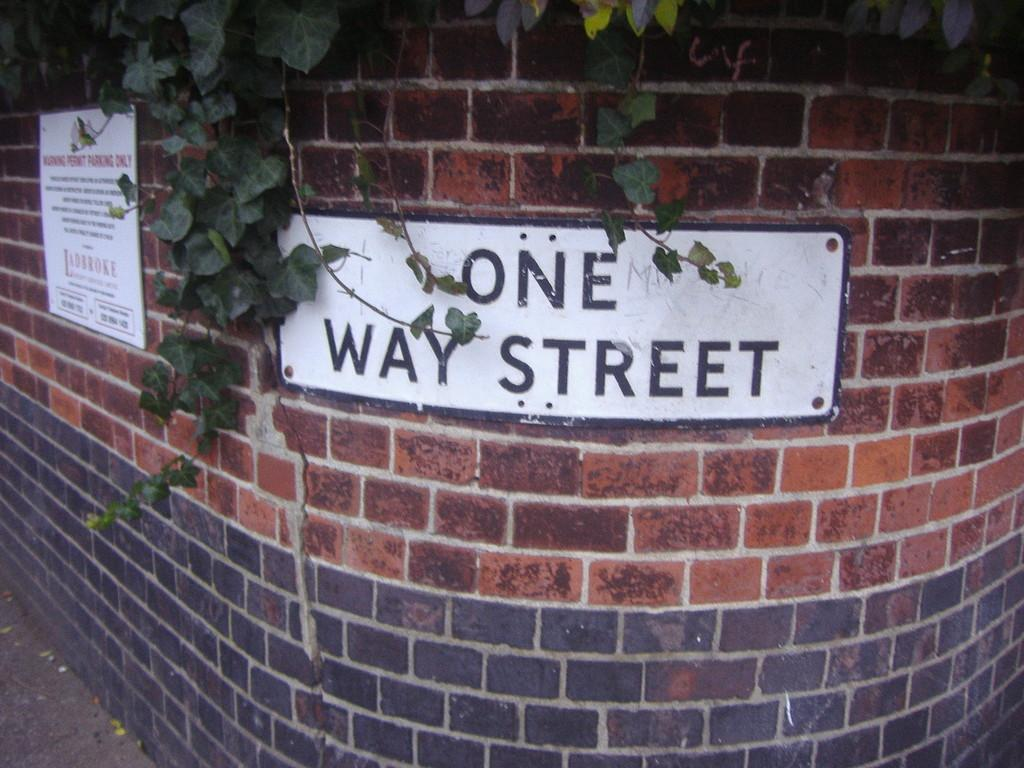What objects with text are present in the image? There are couple boards with text in the image. Where are the boards located? The boards are on a brick wall. What type of vegetation is visible in the image? There are leaves visible in the image. Can you see any planes flying in the image? There are no planes visible in the image. What type of cloth is draped over the boards in the image? There is no cloth draped over the boards in the image; only the boards with text are present. 